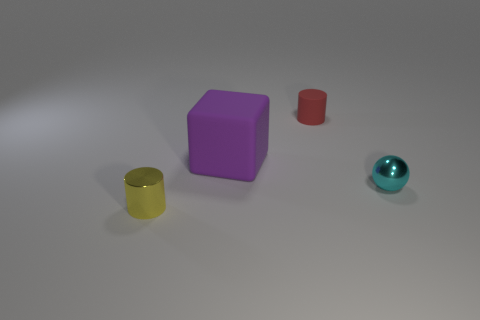What number of cyan metallic balls are there?
Keep it short and to the point. 1. What number of cubes are either metallic objects or big gray shiny objects?
Your answer should be compact. 0. There is a object that is right of the red thing; how many tiny shiny things are to the right of it?
Offer a terse response. 0. Are the ball and the small yellow cylinder made of the same material?
Keep it short and to the point. Yes. Are there any purple objects made of the same material as the small yellow cylinder?
Offer a terse response. No. What color is the cylinder in front of the object right of the cylinder right of the small shiny cylinder?
Ensure brevity in your answer.  Yellow. What number of purple things are big matte objects or small metallic things?
Provide a short and direct response. 1. How many other small matte things have the same shape as the tiny red thing?
Your response must be concise. 0. What is the shape of the yellow metallic thing that is the same size as the red matte cylinder?
Make the answer very short. Cylinder. There is a big object; are there any tiny cyan metallic spheres right of it?
Offer a terse response. Yes. 